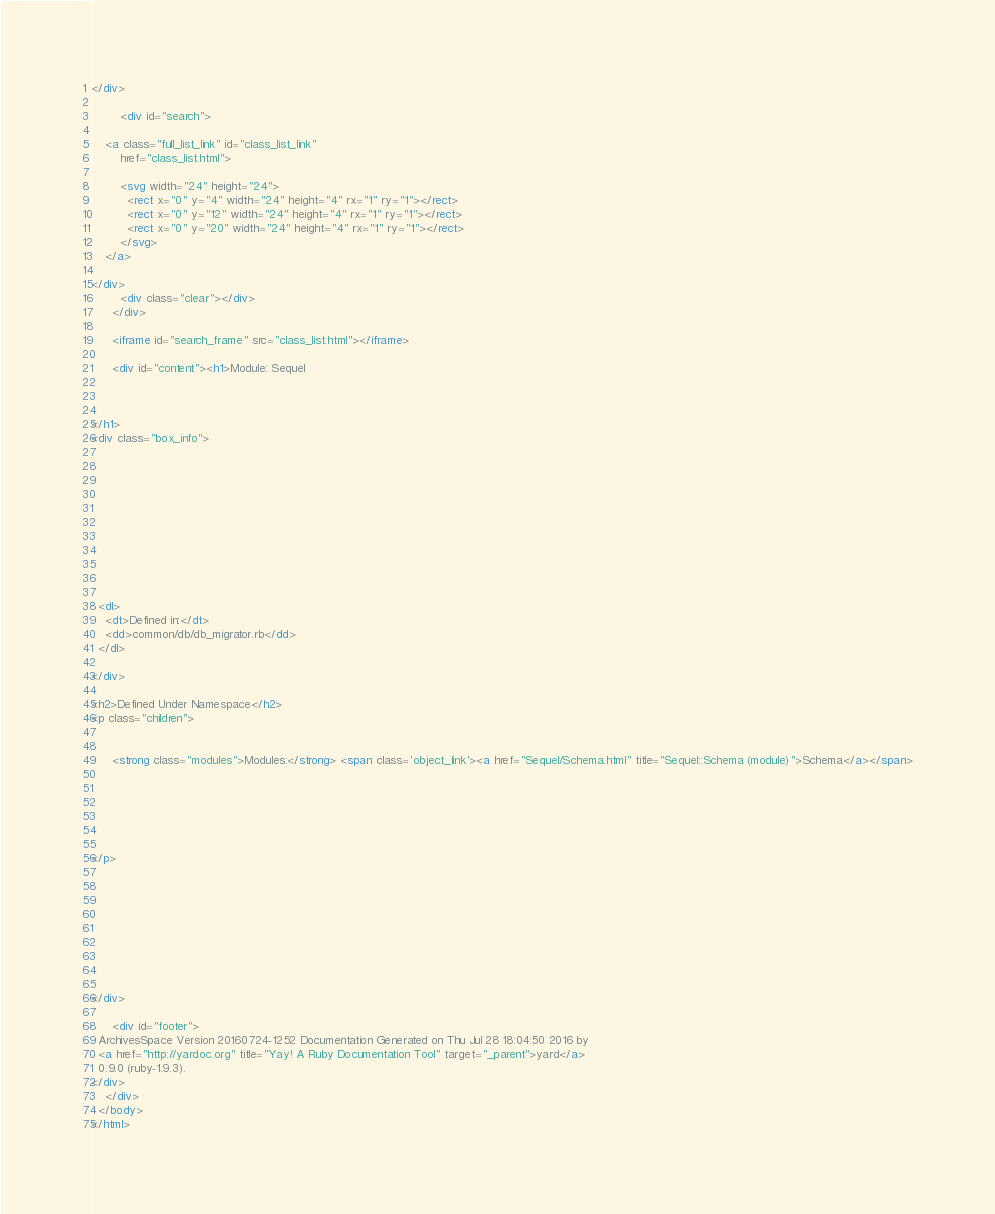<code> <loc_0><loc_0><loc_500><loc_500><_HTML_></div>

        <div id="search">
  
    <a class="full_list_link" id="class_list_link"
        href="class_list.html">

        <svg width="24" height="24">
          <rect x="0" y="4" width="24" height="4" rx="1" ry="1"></rect>
          <rect x="0" y="12" width="24" height="4" rx="1" ry="1"></rect>
          <rect x="0" y="20" width="24" height="4" rx="1" ry="1"></rect>
        </svg>
    </a>
  
</div>
        <div class="clear"></div>
      </div>

      <iframe id="search_frame" src="class_list.html"></iframe>

      <div id="content"><h1>Module: Sequel
  
  
  
</h1>
<div class="box_info">
  

  
  
  
  
  

  

  
  <dl>
    <dt>Defined in:</dt>
    <dd>common/db/db_migrator.rb</dd>
  </dl>
  
</div>

<h2>Defined Under Namespace</h2>
<p class="children">
  
    
      <strong class="modules">Modules:</strong> <span class='object_link'><a href="Sequel/Schema.html" title="Sequel::Schema (module)">Schema</a></span>
    
  
    
  
    
  
</p>









</div>

      <div id="footer">
  ArchivesSpace Version 20160724-1252 Documentation Generated on Thu Jul 28 18:04:50 2016 by
  <a href="http://yardoc.org" title="Yay! A Ruby Documentation Tool" target="_parent">yard</a>
  0.9.0 (ruby-1.9.3).
</div>
    </div>
  </body>
</html></code> 